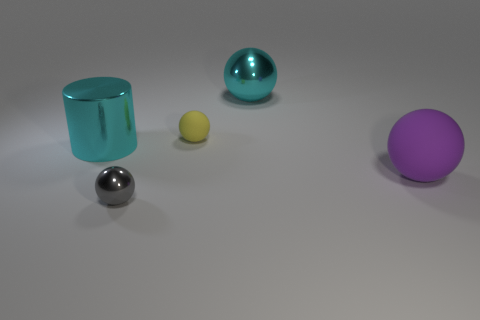Are there any things that are in front of the rubber thing in front of the large shiny thing in front of the tiny yellow rubber object?
Offer a terse response. Yes. Do the big metal thing that is to the left of the tiny metallic ball and the shiny sphere that is behind the shiny cylinder have the same color?
Offer a very short reply. Yes. What material is the other sphere that is the same size as the yellow matte ball?
Your answer should be compact. Metal. What size is the matte thing that is behind the large shiny thing that is left of the ball in front of the purple rubber sphere?
Give a very brief answer. Small. How many other things are there of the same material as the small yellow ball?
Offer a terse response. 1. What size is the cyan thing that is on the right side of the gray shiny thing?
Keep it short and to the point. Large. What number of spheres are both in front of the small yellow object and on the right side of the gray shiny object?
Your answer should be compact. 1. There is a tiny ball that is behind the large cyan metallic object that is left of the gray sphere; what is it made of?
Your response must be concise. Rubber. What material is the large cyan thing that is the same shape as the small metallic thing?
Offer a terse response. Metal. Is there a brown cylinder?
Your response must be concise. No. 